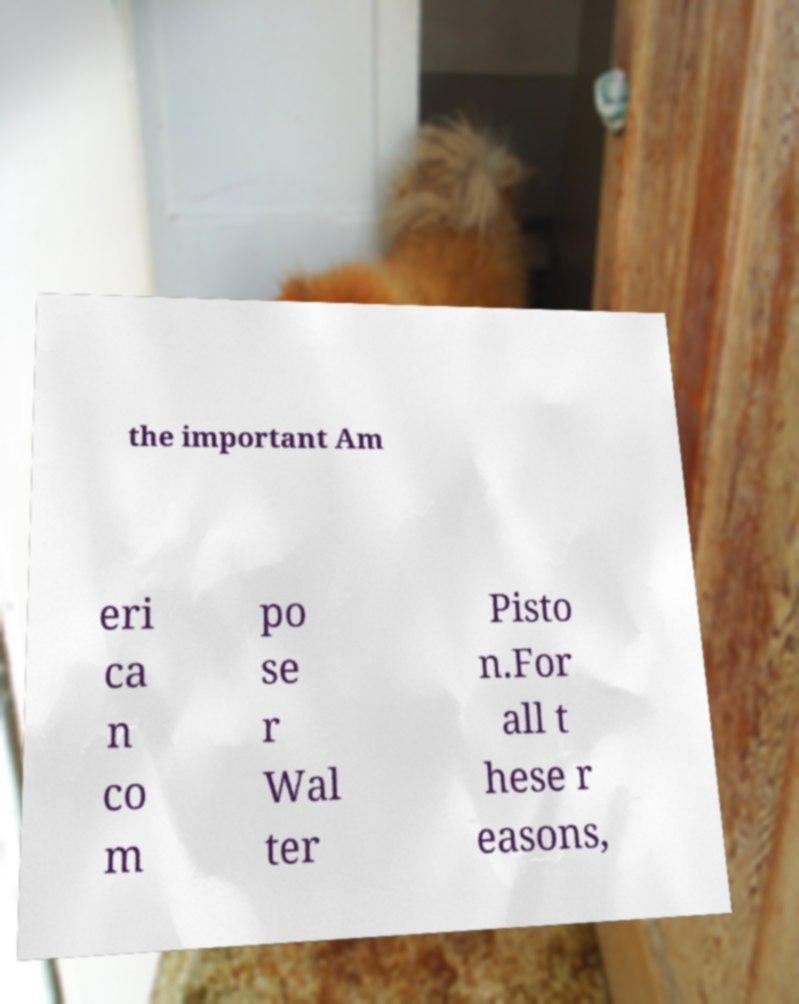I need the written content from this picture converted into text. Can you do that? the important Am eri ca n co m po se r Wal ter Pisto n.For all t hese r easons, 